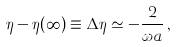Convert formula to latex. <formula><loc_0><loc_0><loc_500><loc_500>\eta - \eta ( \infty ) \equiv \Delta \eta \simeq - \frac { 2 } { \omega a } \, ,</formula> 